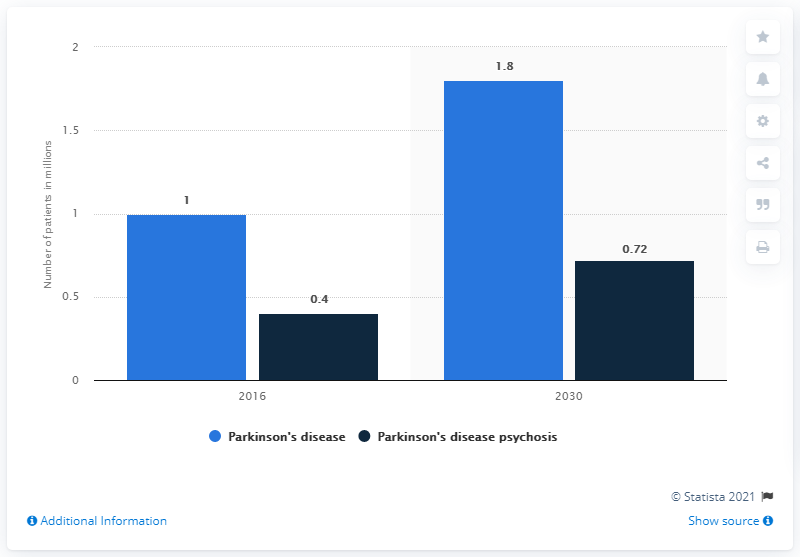Point out several critical features in this image. According to estimates, the number of Parkinson's disease patients is expected to reach 1.8 million by 2030. In 2016, it was estimated that there were approximately 1 million people living with Parkinson's disease in the United States. Parkinson's disease psychosis is the most common disease in the United States, followed by Parkinson's disease. 